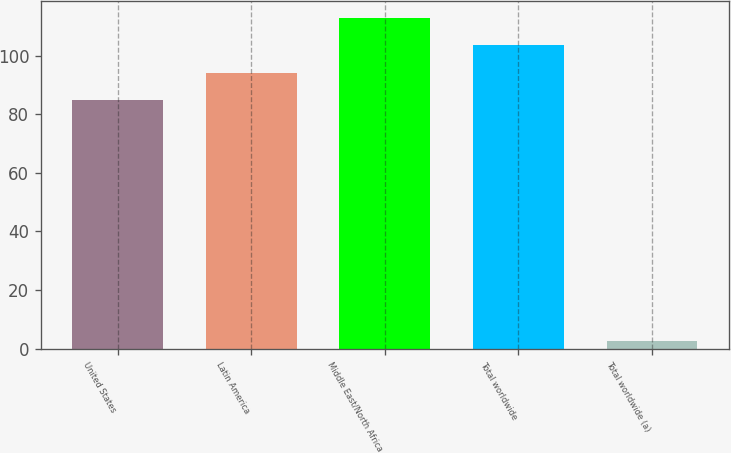Convert chart to OTSL. <chart><loc_0><loc_0><loc_500><loc_500><bar_chart><fcel>United States<fcel>Latin America<fcel>Middle East/North Africa<fcel>Total worldwide<fcel>Total worldwide (a)<nl><fcel>84.73<fcel>94.11<fcel>112.87<fcel>103.49<fcel>2.55<nl></chart> 